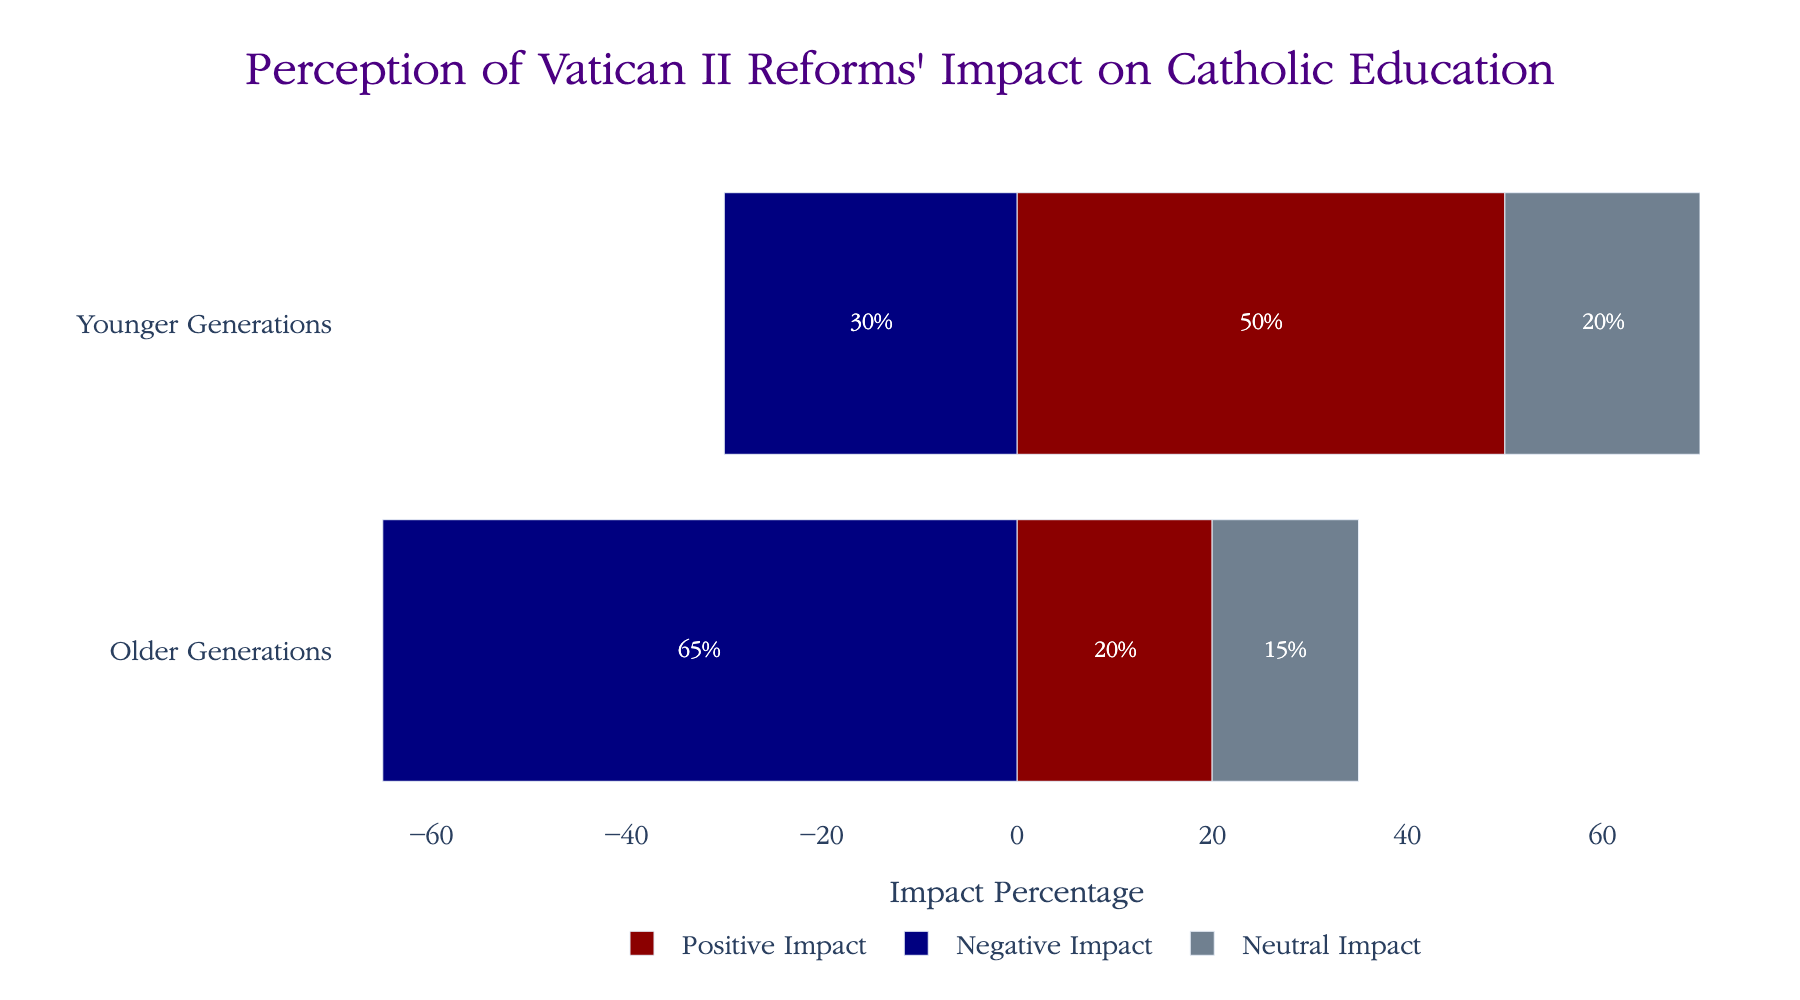What's the difference in positive impact percentages between older and younger generations? The positive impact for older generations is 20%, and for younger generations, it is 50%. Subtract 20% from 50%.
Answer: 30% Which generation perceives a higher negative impact of the Vatican II reforms? The negative impact is represented by -65% for older generations and -30% for younger generations. Since -65% is more negative than -30%, older generations perceive a higher negative impact.
Answer: Older Generations What is the combined percentage of neutral and positive impact for the younger generation? The positive impact for the younger generation is 50%, and the neutral impact is 20%. Adding these together gives 50% + 20%.
Answer: 70% How much more neutral impact do younger generations see compared to older generations? The neutral impact for older generations is 15%, while for younger generations, it is 20%. Subtract 15% from 20%.
Answer: 5% Compare the total perceived impact (sum of positive, negative, and neutral) between the two generations. Which generation perceives a greater total impact? For older generations, the total perceived impact = 20% + 65% + 15% = 100%. For younger generations, the total perceived impact = 50% + 30% + 20% = 100%. Both have the same total perceived impact.
Answer: Equal What is the ratio of positive to negative impacts for older generations? The positive impact is 20%, and the negative impact is 65%. The ratio is 20% to 65%. Simplify the ratio 20:65 by dividing both parts by their greatest common divisor, which is 5, resulting in 4:13.
Answer: 4:13 What is the total percentage of older generations that do not have a negative perception of the reforms? The neutral and positive perceptions for older generations are 15% and 20% respectively. Adding these together gives 15% + 20%.
Answer: 35% Which category has the largest discrepancy between older and younger generations? The differences are: 
Positive: 50% - 20% = 30%, 
Negative: 65% - 30% = 35%, 
Neutral: 20% - 15% = 5%. 
The largest discrepancy is in the negative impact category.
Answer: Negative Impact What percentage of the younger generation has a neutral view of the Vatican II reforms? The neutral impact for the younger generation is explicitly shown as 20% in the figure.
Answer: 20% What is the difference between the positive and neutral impacts for younger generations? The positive impact for younger generations is 50%, and the neutral impact is 20%. Subtract 20% from 50%.
Answer: 30% 